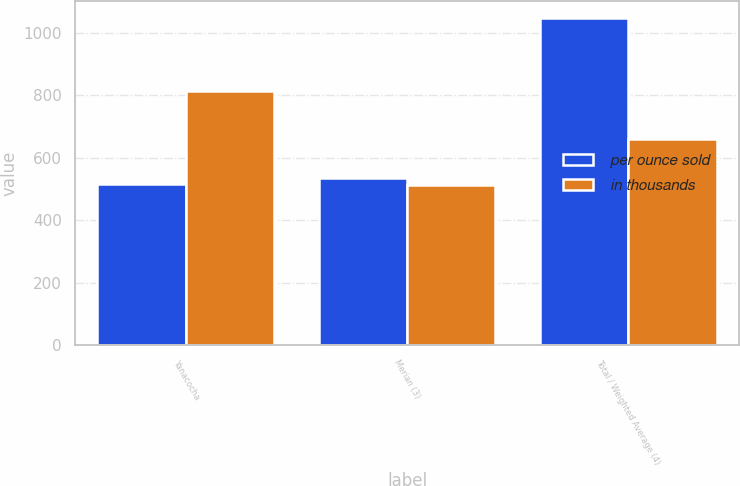<chart> <loc_0><loc_0><loc_500><loc_500><stacked_bar_chart><ecel><fcel>Yanacocha<fcel>Merian (3)<fcel>Total / Weighted Average (4)<nl><fcel>per ounce sold<fcel>515<fcel>534<fcel>1049<nl><fcel>in thousands<fcel>813<fcel>512<fcel>660<nl></chart> 